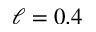Convert formula to latex. <formula><loc_0><loc_0><loc_500><loc_500>\ell = 0 . 4</formula> 